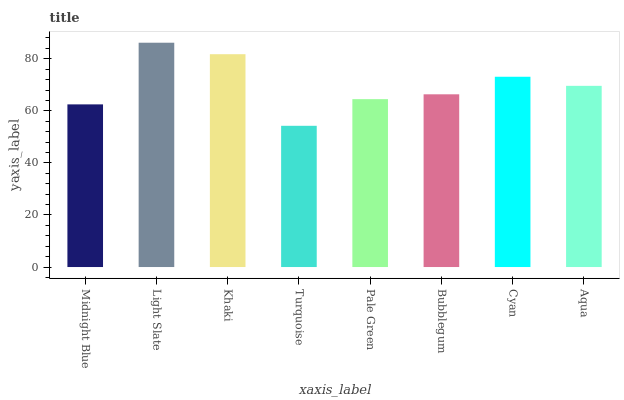Is Turquoise the minimum?
Answer yes or no. Yes. Is Light Slate the maximum?
Answer yes or no. Yes. Is Khaki the minimum?
Answer yes or no. No. Is Khaki the maximum?
Answer yes or no. No. Is Light Slate greater than Khaki?
Answer yes or no. Yes. Is Khaki less than Light Slate?
Answer yes or no. Yes. Is Khaki greater than Light Slate?
Answer yes or no. No. Is Light Slate less than Khaki?
Answer yes or no. No. Is Aqua the high median?
Answer yes or no. Yes. Is Bubblegum the low median?
Answer yes or no. Yes. Is Pale Green the high median?
Answer yes or no. No. Is Aqua the low median?
Answer yes or no. No. 